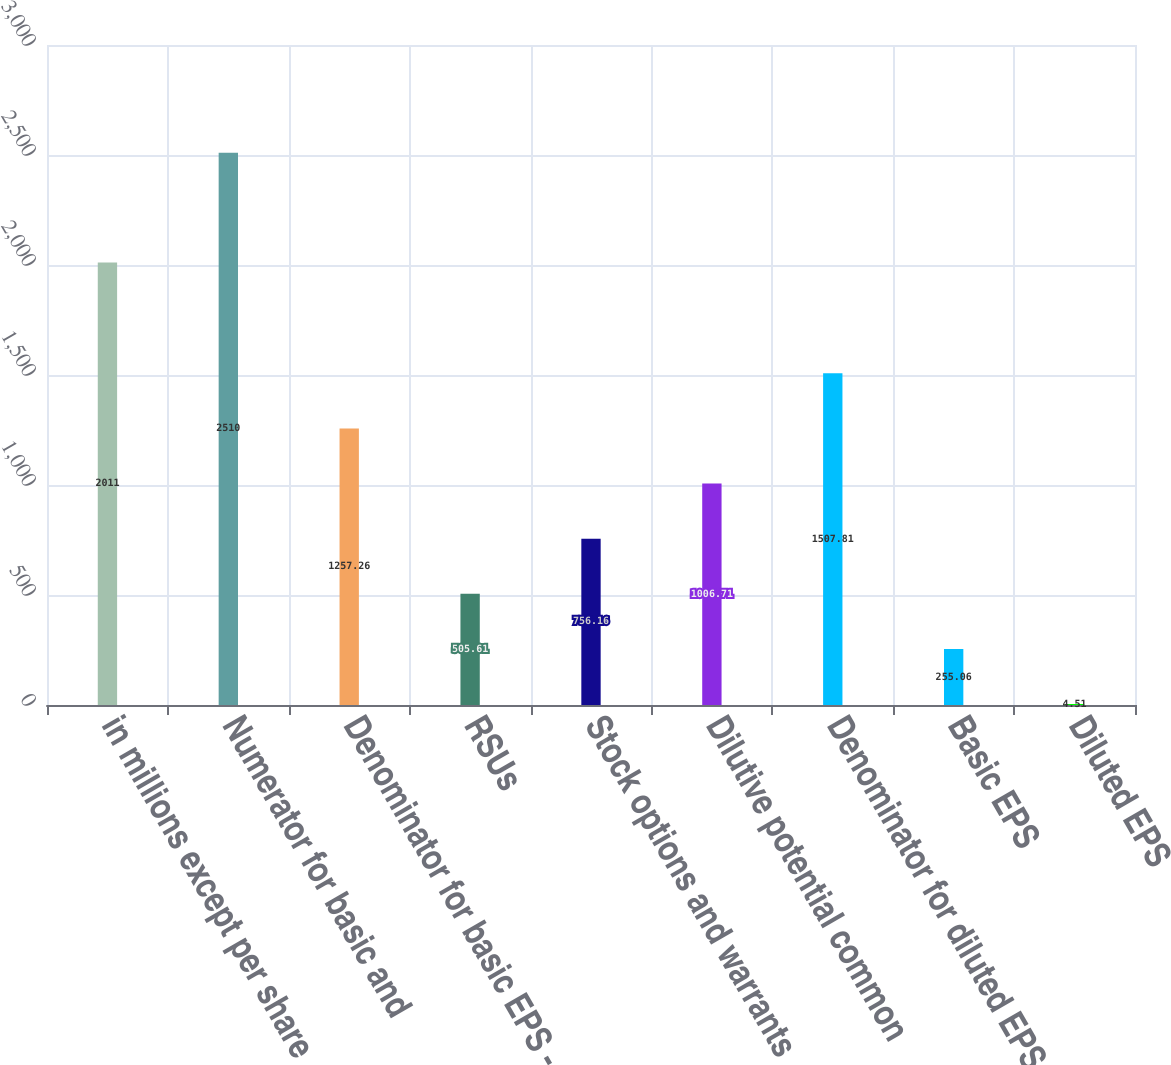<chart> <loc_0><loc_0><loc_500><loc_500><bar_chart><fcel>in millions except per share<fcel>Numerator for basic and<fcel>Denominator for basic EPS -<fcel>RSUs<fcel>Stock options and warrants<fcel>Dilutive potential common<fcel>Denominator for diluted EPS -<fcel>Basic EPS<fcel>Diluted EPS<nl><fcel>2011<fcel>2510<fcel>1257.26<fcel>505.61<fcel>756.16<fcel>1006.71<fcel>1507.81<fcel>255.06<fcel>4.51<nl></chart> 